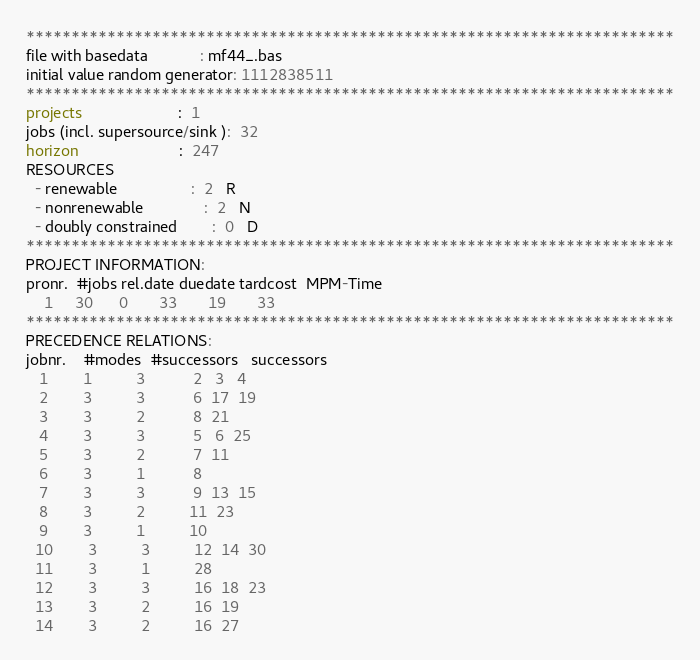Convert code to text. <code><loc_0><loc_0><loc_500><loc_500><_ObjectiveC_>************************************************************************
file with basedata            : mf44_.bas
initial value random generator: 1112838511
************************************************************************
projects                      :  1
jobs (incl. supersource/sink ):  32
horizon                       :  247
RESOURCES
  - renewable                 :  2   R
  - nonrenewable              :  2   N
  - doubly constrained        :  0   D
************************************************************************
PROJECT INFORMATION:
pronr.  #jobs rel.date duedate tardcost  MPM-Time
    1     30      0       33       19       33
************************************************************************
PRECEDENCE RELATIONS:
jobnr.    #modes  #successors   successors
   1        1          3           2   3   4
   2        3          3           6  17  19
   3        3          2           8  21
   4        3          3           5   6  25
   5        3          2           7  11
   6        3          1           8
   7        3          3           9  13  15
   8        3          2          11  23
   9        3          1          10
  10        3          3          12  14  30
  11        3          1          28
  12        3          3          16  18  23
  13        3          2          16  19
  14        3          2          16  27</code> 